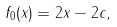Convert formula to latex. <formula><loc_0><loc_0><loc_500><loc_500>f _ { 0 } ( x ) = 2 x - 2 c ,</formula> 